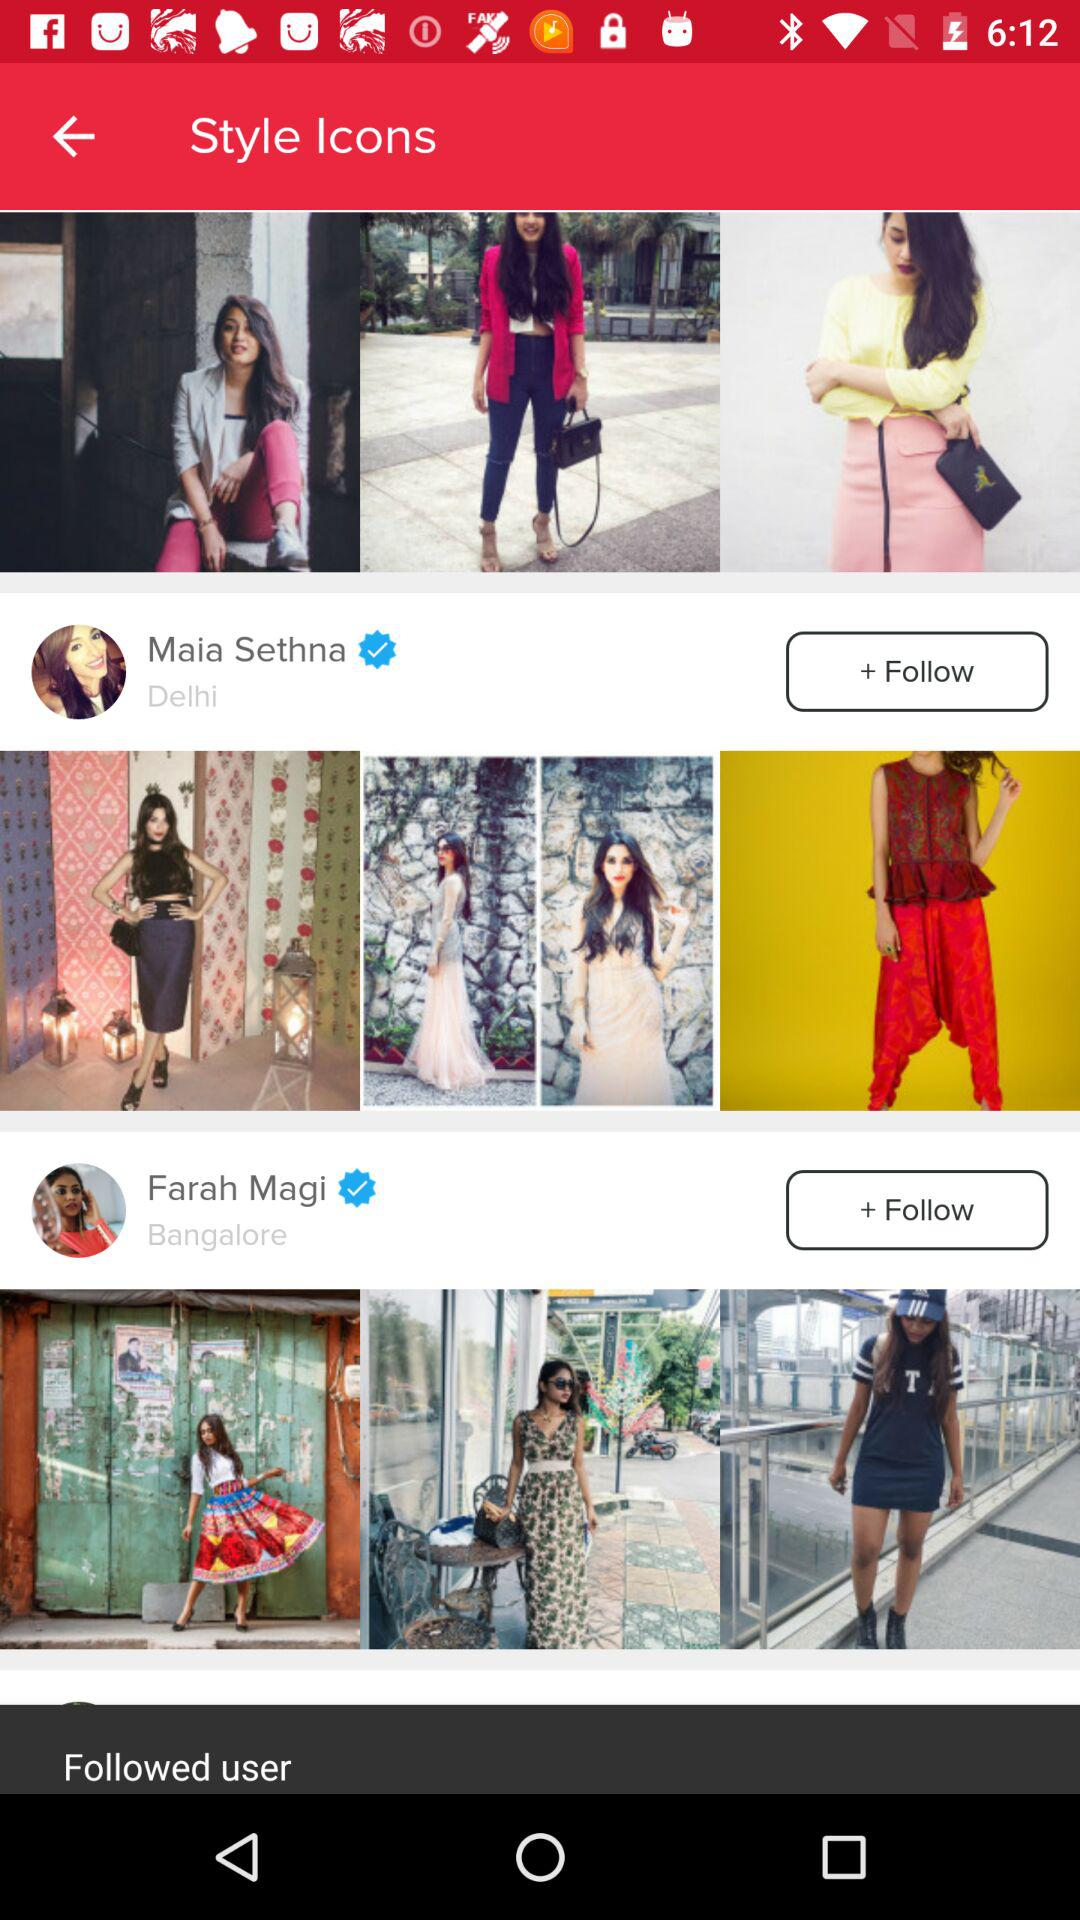What is the location of Farah Magi? The location of Farah Magi is Bangalore. 